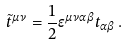<formula> <loc_0><loc_0><loc_500><loc_500>\tilde { t } ^ { \mu \nu } = \frac { 1 } { 2 } \epsilon ^ { \mu \nu \alpha \beta } t _ { \alpha \beta } \, .</formula> 